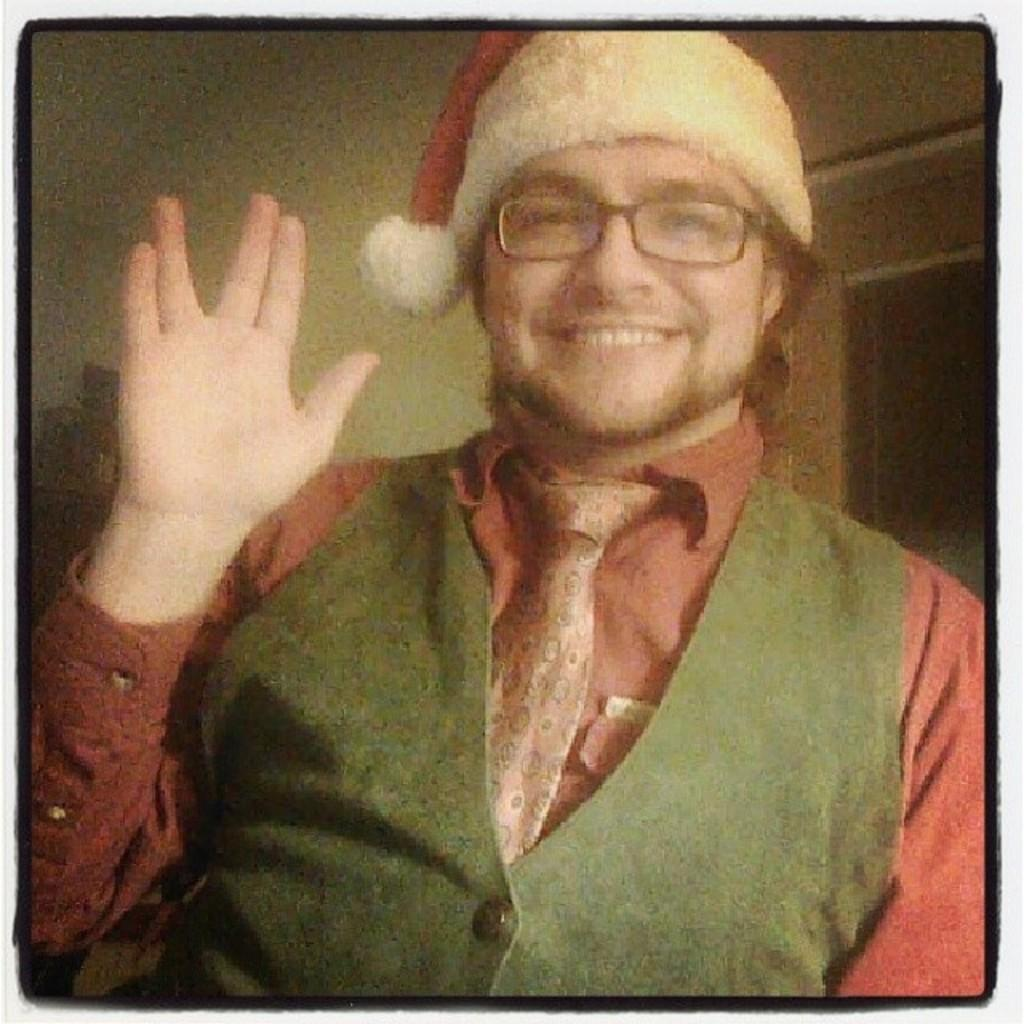Who is present in the image? There is a man in the image. What is the man doing in the image? The man is smiling in the image. What is the man wearing on his upper body? The man is wearing a red color shirt and a green waistcoat. What accessory is the man wearing on his head? The man is wearing a Christmas cap. What type of bun is the man holding in the image? There is no bun present in the image. What kind of operation is the man performing in the image? The man is not performing any operation in the image; he is simply smiling and wearing specific clothing. 